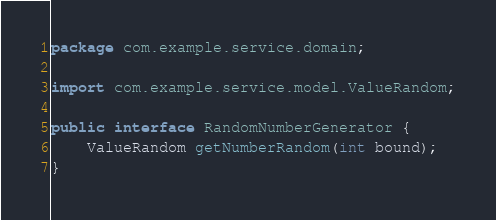<code> <loc_0><loc_0><loc_500><loc_500><_Java_>package com.example.service.domain;

import com.example.service.model.ValueRandom;

public interface RandomNumberGenerator {
    ValueRandom getNumberRandom(int bound);
}
</code> 